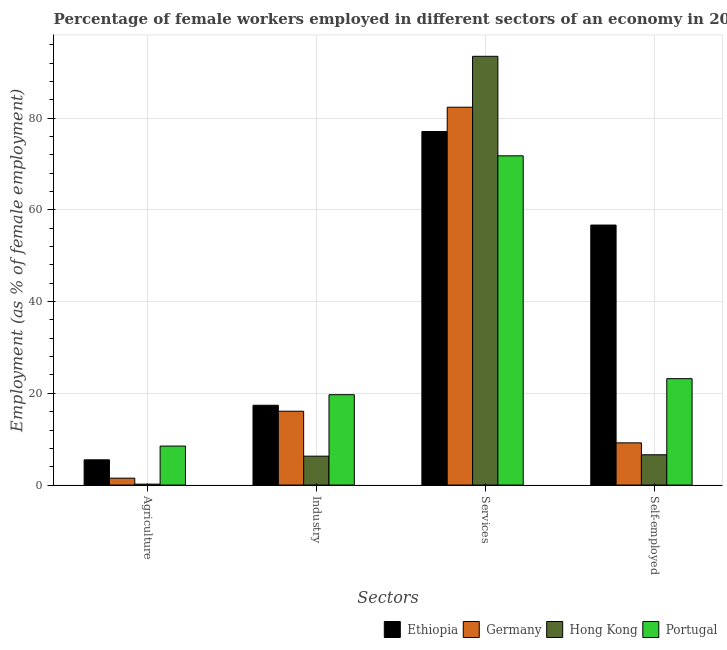How many groups of bars are there?
Offer a terse response. 4. Are the number of bars on each tick of the X-axis equal?
Provide a short and direct response. Yes. How many bars are there on the 3rd tick from the left?
Your response must be concise. 4. How many bars are there on the 3rd tick from the right?
Your answer should be compact. 4. What is the label of the 3rd group of bars from the left?
Provide a succinct answer. Services. What is the percentage of female workers in agriculture in Portugal?
Your answer should be very brief. 8.5. Across all countries, what is the minimum percentage of female workers in industry?
Your answer should be compact. 6.3. In which country was the percentage of self employed female workers maximum?
Ensure brevity in your answer.  Ethiopia. In which country was the percentage of female workers in industry minimum?
Give a very brief answer. Hong Kong. What is the total percentage of self employed female workers in the graph?
Provide a short and direct response. 95.7. What is the difference between the percentage of self employed female workers in Germany and that in Portugal?
Keep it short and to the point. -14. What is the difference between the percentage of female workers in agriculture in Ethiopia and the percentage of female workers in industry in Portugal?
Your answer should be compact. -14.2. What is the average percentage of self employed female workers per country?
Your response must be concise. 23.93. What is the difference between the percentage of self employed female workers and percentage of female workers in agriculture in Ethiopia?
Give a very brief answer. 51.2. In how many countries, is the percentage of self employed female workers greater than 92 %?
Your response must be concise. 0. What is the ratio of the percentage of female workers in services in Germany to that in Hong Kong?
Keep it short and to the point. 0.88. What is the difference between the highest and the second highest percentage of female workers in services?
Your response must be concise. 11.1. What is the difference between the highest and the lowest percentage of female workers in industry?
Keep it short and to the point. 13.4. What does the 3rd bar from the left in Industry represents?
Make the answer very short. Hong Kong. Is it the case that in every country, the sum of the percentage of female workers in agriculture and percentage of female workers in industry is greater than the percentage of female workers in services?
Your answer should be very brief. No. How many bars are there?
Make the answer very short. 16. How many countries are there in the graph?
Your answer should be compact. 4. What is the difference between two consecutive major ticks on the Y-axis?
Give a very brief answer. 20. Does the graph contain grids?
Give a very brief answer. Yes. How many legend labels are there?
Your answer should be very brief. 4. What is the title of the graph?
Keep it short and to the point. Percentage of female workers employed in different sectors of an economy in 2006. Does "Macedonia" appear as one of the legend labels in the graph?
Ensure brevity in your answer.  No. What is the label or title of the X-axis?
Offer a very short reply. Sectors. What is the label or title of the Y-axis?
Ensure brevity in your answer.  Employment (as % of female employment). What is the Employment (as % of female employment) of Germany in Agriculture?
Your response must be concise. 1.5. What is the Employment (as % of female employment) in Hong Kong in Agriculture?
Give a very brief answer. 0.2. What is the Employment (as % of female employment) in Ethiopia in Industry?
Offer a terse response. 17.4. What is the Employment (as % of female employment) of Germany in Industry?
Keep it short and to the point. 16.1. What is the Employment (as % of female employment) of Hong Kong in Industry?
Offer a terse response. 6.3. What is the Employment (as % of female employment) of Portugal in Industry?
Ensure brevity in your answer.  19.7. What is the Employment (as % of female employment) of Ethiopia in Services?
Keep it short and to the point. 77.1. What is the Employment (as % of female employment) of Germany in Services?
Give a very brief answer. 82.4. What is the Employment (as % of female employment) in Hong Kong in Services?
Your answer should be compact. 93.5. What is the Employment (as % of female employment) of Portugal in Services?
Provide a short and direct response. 71.8. What is the Employment (as % of female employment) of Ethiopia in Self-employed?
Offer a terse response. 56.7. What is the Employment (as % of female employment) of Germany in Self-employed?
Provide a succinct answer. 9.2. What is the Employment (as % of female employment) of Hong Kong in Self-employed?
Your response must be concise. 6.6. What is the Employment (as % of female employment) of Portugal in Self-employed?
Your answer should be very brief. 23.2. Across all Sectors, what is the maximum Employment (as % of female employment) in Ethiopia?
Your answer should be very brief. 77.1. Across all Sectors, what is the maximum Employment (as % of female employment) in Germany?
Your answer should be compact. 82.4. Across all Sectors, what is the maximum Employment (as % of female employment) of Hong Kong?
Give a very brief answer. 93.5. Across all Sectors, what is the maximum Employment (as % of female employment) in Portugal?
Offer a very short reply. 71.8. Across all Sectors, what is the minimum Employment (as % of female employment) of Germany?
Your response must be concise. 1.5. Across all Sectors, what is the minimum Employment (as % of female employment) in Hong Kong?
Ensure brevity in your answer.  0.2. What is the total Employment (as % of female employment) in Ethiopia in the graph?
Your response must be concise. 156.7. What is the total Employment (as % of female employment) in Germany in the graph?
Give a very brief answer. 109.2. What is the total Employment (as % of female employment) of Hong Kong in the graph?
Your answer should be compact. 106.6. What is the total Employment (as % of female employment) of Portugal in the graph?
Provide a succinct answer. 123.2. What is the difference between the Employment (as % of female employment) of Germany in Agriculture and that in Industry?
Your answer should be compact. -14.6. What is the difference between the Employment (as % of female employment) of Portugal in Agriculture and that in Industry?
Make the answer very short. -11.2. What is the difference between the Employment (as % of female employment) in Ethiopia in Agriculture and that in Services?
Ensure brevity in your answer.  -71.6. What is the difference between the Employment (as % of female employment) of Germany in Agriculture and that in Services?
Provide a short and direct response. -80.9. What is the difference between the Employment (as % of female employment) of Hong Kong in Agriculture and that in Services?
Your response must be concise. -93.3. What is the difference between the Employment (as % of female employment) in Portugal in Agriculture and that in Services?
Keep it short and to the point. -63.3. What is the difference between the Employment (as % of female employment) of Ethiopia in Agriculture and that in Self-employed?
Make the answer very short. -51.2. What is the difference between the Employment (as % of female employment) of Germany in Agriculture and that in Self-employed?
Offer a terse response. -7.7. What is the difference between the Employment (as % of female employment) of Hong Kong in Agriculture and that in Self-employed?
Provide a short and direct response. -6.4. What is the difference between the Employment (as % of female employment) in Portugal in Agriculture and that in Self-employed?
Keep it short and to the point. -14.7. What is the difference between the Employment (as % of female employment) in Ethiopia in Industry and that in Services?
Provide a succinct answer. -59.7. What is the difference between the Employment (as % of female employment) in Germany in Industry and that in Services?
Offer a terse response. -66.3. What is the difference between the Employment (as % of female employment) in Hong Kong in Industry and that in Services?
Provide a succinct answer. -87.2. What is the difference between the Employment (as % of female employment) of Portugal in Industry and that in Services?
Provide a succinct answer. -52.1. What is the difference between the Employment (as % of female employment) in Ethiopia in Industry and that in Self-employed?
Your answer should be very brief. -39.3. What is the difference between the Employment (as % of female employment) in Portugal in Industry and that in Self-employed?
Keep it short and to the point. -3.5. What is the difference between the Employment (as % of female employment) of Ethiopia in Services and that in Self-employed?
Offer a terse response. 20.4. What is the difference between the Employment (as % of female employment) in Germany in Services and that in Self-employed?
Provide a succinct answer. 73.2. What is the difference between the Employment (as % of female employment) of Hong Kong in Services and that in Self-employed?
Ensure brevity in your answer.  86.9. What is the difference between the Employment (as % of female employment) of Portugal in Services and that in Self-employed?
Your response must be concise. 48.6. What is the difference between the Employment (as % of female employment) of Ethiopia in Agriculture and the Employment (as % of female employment) of Germany in Industry?
Your answer should be very brief. -10.6. What is the difference between the Employment (as % of female employment) in Ethiopia in Agriculture and the Employment (as % of female employment) in Hong Kong in Industry?
Keep it short and to the point. -0.8. What is the difference between the Employment (as % of female employment) of Germany in Agriculture and the Employment (as % of female employment) of Hong Kong in Industry?
Offer a terse response. -4.8. What is the difference between the Employment (as % of female employment) of Germany in Agriculture and the Employment (as % of female employment) of Portugal in Industry?
Give a very brief answer. -18.2. What is the difference between the Employment (as % of female employment) in Hong Kong in Agriculture and the Employment (as % of female employment) in Portugal in Industry?
Provide a succinct answer. -19.5. What is the difference between the Employment (as % of female employment) in Ethiopia in Agriculture and the Employment (as % of female employment) in Germany in Services?
Offer a terse response. -76.9. What is the difference between the Employment (as % of female employment) of Ethiopia in Agriculture and the Employment (as % of female employment) of Hong Kong in Services?
Give a very brief answer. -88. What is the difference between the Employment (as % of female employment) of Ethiopia in Agriculture and the Employment (as % of female employment) of Portugal in Services?
Your answer should be very brief. -66.3. What is the difference between the Employment (as % of female employment) in Germany in Agriculture and the Employment (as % of female employment) in Hong Kong in Services?
Your answer should be very brief. -92. What is the difference between the Employment (as % of female employment) in Germany in Agriculture and the Employment (as % of female employment) in Portugal in Services?
Offer a very short reply. -70.3. What is the difference between the Employment (as % of female employment) of Hong Kong in Agriculture and the Employment (as % of female employment) of Portugal in Services?
Give a very brief answer. -71.6. What is the difference between the Employment (as % of female employment) in Ethiopia in Agriculture and the Employment (as % of female employment) in Hong Kong in Self-employed?
Offer a very short reply. -1.1. What is the difference between the Employment (as % of female employment) of Ethiopia in Agriculture and the Employment (as % of female employment) of Portugal in Self-employed?
Ensure brevity in your answer.  -17.7. What is the difference between the Employment (as % of female employment) of Germany in Agriculture and the Employment (as % of female employment) of Portugal in Self-employed?
Your answer should be very brief. -21.7. What is the difference between the Employment (as % of female employment) in Ethiopia in Industry and the Employment (as % of female employment) in Germany in Services?
Offer a terse response. -65. What is the difference between the Employment (as % of female employment) of Ethiopia in Industry and the Employment (as % of female employment) of Hong Kong in Services?
Offer a very short reply. -76.1. What is the difference between the Employment (as % of female employment) of Ethiopia in Industry and the Employment (as % of female employment) of Portugal in Services?
Give a very brief answer. -54.4. What is the difference between the Employment (as % of female employment) of Germany in Industry and the Employment (as % of female employment) of Hong Kong in Services?
Your answer should be compact. -77.4. What is the difference between the Employment (as % of female employment) in Germany in Industry and the Employment (as % of female employment) in Portugal in Services?
Your answer should be compact. -55.7. What is the difference between the Employment (as % of female employment) of Hong Kong in Industry and the Employment (as % of female employment) of Portugal in Services?
Your answer should be very brief. -65.5. What is the difference between the Employment (as % of female employment) of Ethiopia in Industry and the Employment (as % of female employment) of Hong Kong in Self-employed?
Give a very brief answer. 10.8. What is the difference between the Employment (as % of female employment) in Germany in Industry and the Employment (as % of female employment) in Hong Kong in Self-employed?
Give a very brief answer. 9.5. What is the difference between the Employment (as % of female employment) of Hong Kong in Industry and the Employment (as % of female employment) of Portugal in Self-employed?
Provide a succinct answer. -16.9. What is the difference between the Employment (as % of female employment) in Ethiopia in Services and the Employment (as % of female employment) in Germany in Self-employed?
Provide a short and direct response. 67.9. What is the difference between the Employment (as % of female employment) of Ethiopia in Services and the Employment (as % of female employment) of Hong Kong in Self-employed?
Your answer should be very brief. 70.5. What is the difference between the Employment (as % of female employment) in Ethiopia in Services and the Employment (as % of female employment) in Portugal in Self-employed?
Offer a terse response. 53.9. What is the difference between the Employment (as % of female employment) of Germany in Services and the Employment (as % of female employment) of Hong Kong in Self-employed?
Offer a very short reply. 75.8. What is the difference between the Employment (as % of female employment) in Germany in Services and the Employment (as % of female employment) in Portugal in Self-employed?
Keep it short and to the point. 59.2. What is the difference between the Employment (as % of female employment) in Hong Kong in Services and the Employment (as % of female employment) in Portugal in Self-employed?
Ensure brevity in your answer.  70.3. What is the average Employment (as % of female employment) in Ethiopia per Sectors?
Your answer should be very brief. 39.17. What is the average Employment (as % of female employment) in Germany per Sectors?
Offer a terse response. 27.3. What is the average Employment (as % of female employment) of Hong Kong per Sectors?
Offer a terse response. 26.65. What is the average Employment (as % of female employment) in Portugal per Sectors?
Your answer should be very brief. 30.8. What is the difference between the Employment (as % of female employment) of Ethiopia and Employment (as % of female employment) of Germany in Agriculture?
Your answer should be very brief. 4. What is the difference between the Employment (as % of female employment) in Ethiopia and Employment (as % of female employment) in Portugal in Agriculture?
Offer a very short reply. -3. What is the difference between the Employment (as % of female employment) in Germany and Employment (as % of female employment) in Portugal in Agriculture?
Keep it short and to the point. -7. What is the difference between the Employment (as % of female employment) of Hong Kong and Employment (as % of female employment) of Portugal in Agriculture?
Your answer should be very brief. -8.3. What is the difference between the Employment (as % of female employment) of Ethiopia and Employment (as % of female employment) of Germany in Industry?
Make the answer very short. 1.3. What is the difference between the Employment (as % of female employment) of Ethiopia and Employment (as % of female employment) of Portugal in Industry?
Ensure brevity in your answer.  -2.3. What is the difference between the Employment (as % of female employment) of Germany and Employment (as % of female employment) of Hong Kong in Industry?
Keep it short and to the point. 9.8. What is the difference between the Employment (as % of female employment) of Hong Kong and Employment (as % of female employment) of Portugal in Industry?
Your response must be concise. -13.4. What is the difference between the Employment (as % of female employment) of Ethiopia and Employment (as % of female employment) of Germany in Services?
Provide a short and direct response. -5.3. What is the difference between the Employment (as % of female employment) in Ethiopia and Employment (as % of female employment) in Hong Kong in Services?
Ensure brevity in your answer.  -16.4. What is the difference between the Employment (as % of female employment) of Germany and Employment (as % of female employment) of Hong Kong in Services?
Ensure brevity in your answer.  -11.1. What is the difference between the Employment (as % of female employment) in Germany and Employment (as % of female employment) in Portugal in Services?
Offer a terse response. 10.6. What is the difference between the Employment (as % of female employment) in Hong Kong and Employment (as % of female employment) in Portugal in Services?
Your answer should be compact. 21.7. What is the difference between the Employment (as % of female employment) in Ethiopia and Employment (as % of female employment) in Germany in Self-employed?
Offer a terse response. 47.5. What is the difference between the Employment (as % of female employment) of Ethiopia and Employment (as % of female employment) of Hong Kong in Self-employed?
Your answer should be compact. 50.1. What is the difference between the Employment (as % of female employment) of Ethiopia and Employment (as % of female employment) of Portugal in Self-employed?
Your response must be concise. 33.5. What is the difference between the Employment (as % of female employment) in Germany and Employment (as % of female employment) in Portugal in Self-employed?
Provide a short and direct response. -14. What is the difference between the Employment (as % of female employment) of Hong Kong and Employment (as % of female employment) of Portugal in Self-employed?
Keep it short and to the point. -16.6. What is the ratio of the Employment (as % of female employment) in Ethiopia in Agriculture to that in Industry?
Offer a very short reply. 0.32. What is the ratio of the Employment (as % of female employment) of Germany in Agriculture to that in Industry?
Your answer should be compact. 0.09. What is the ratio of the Employment (as % of female employment) of Hong Kong in Agriculture to that in Industry?
Offer a terse response. 0.03. What is the ratio of the Employment (as % of female employment) in Portugal in Agriculture to that in Industry?
Ensure brevity in your answer.  0.43. What is the ratio of the Employment (as % of female employment) of Ethiopia in Agriculture to that in Services?
Ensure brevity in your answer.  0.07. What is the ratio of the Employment (as % of female employment) in Germany in Agriculture to that in Services?
Provide a short and direct response. 0.02. What is the ratio of the Employment (as % of female employment) in Hong Kong in Agriculture to that in Services?
Provide a short and direct response. 0. What is the ratio of the Employment (as % of female employment) of Portugal in Agriculture to that in Services?
Keep it short and to the point. 0.12. What is the ratio of the Employment (as % of female employment) of Ethiopia in Agriculture to that in Self-employed?
Offer a very short reply. 0.1. What is the ratio of the Employment (as % of female employment) in Germany in Agriculture to that in Self-employed?
Your answer should be very brief. 0.16. What is the ratio of the Employment (as % of female employment) of Hong Kong in Agriculture to that in Self-employed?
Ensure brevity in your answer.  0.03. What is the ratio of the Employment (as % of female employment) of Portugal in Agriculture to that in Self-employed?
Offer a terse response. 0.37. What is the ratio of the Employment (as % of female employment) in Ethiopia in Industry to that in Services?
Provide a short and direct response. 0.23. What is the ratio of the Employment (as % of female employment) in Germany in Industry to that in Services?
Provide a short and direct response. 0.2. What is the ratio of the Employment (as % of female employment) of Hong Kong in Industry to that in Services?
Offer a terse response. 0.07. What is the ratio of the Employment (as % of female employment) of Portugal in Industry to that in Services?
Make the answer very short. 0.27. What is the ratio of the Employment (as % of female employment) of Ethiopia in Industry to that in Self-employed?
Provide a succinct answer. 0.31. What is the ratio of the Employment (as % of female employment) in Hong Kong in Industry to that in Self-employed?
Make the answer very short. 0.95. What is the ratio of the Employment (as % of female employment) of Portugal in Industry to that in Self-employed?
Your response must be concise. 0.85. What is the ratio of the Employment (as % of female employment) in Ethiopia in Services to that in Self-employed?
Provide a succinct answer. 1.36. What is the ratio of the Employment (as % of female employment) of Germany in Services to that in Self-employed?
Provide a short and direct response. 8.96. What is the ratio of the Employment (as % of female employment) in Hong Kong in Services to that in Self-employed?
Provide a short and direct response. 14.17. What is the ratio of the Employment (as % of female employment) in Portugal in Services to that in Self-employed?
Keep it short and to the point. 3.09. What is the difference between the highest and the second highest Employment (as % of female employment) in Ethiopia?
Offer a terse response. 20.4. What is the difference between the highest and the second highest Employment (as % of female employment) in Germany?
Provide a succinct answer. 66.3. What is the difference between the highest and the second highest Employment (as % of female employment) of Hong Kong?
Your answer should be very brief. 86.9. What is the difference between the highest and the second highest Employment (as % of female employment) in Portugal?
Provide a succinct answer. 48.6. What is the difference between the highest and the lowest Employment (as % of female employment) of Ethiopia?
Provide a succinct answer. 71.6. What is the difference between the highest and the lowest Employment (as % of female employment) of Germany?
Your answer should be compact. 80.9. What is the difference between the highest and the lowest Employment (as % of female employment) in Hong Kong?
Provide a succinct answer. 93.3. What is the difference between the highest and the lowest Employment (as % of female employment) in Portugal?
Provide a succinct answer. 63.3. 